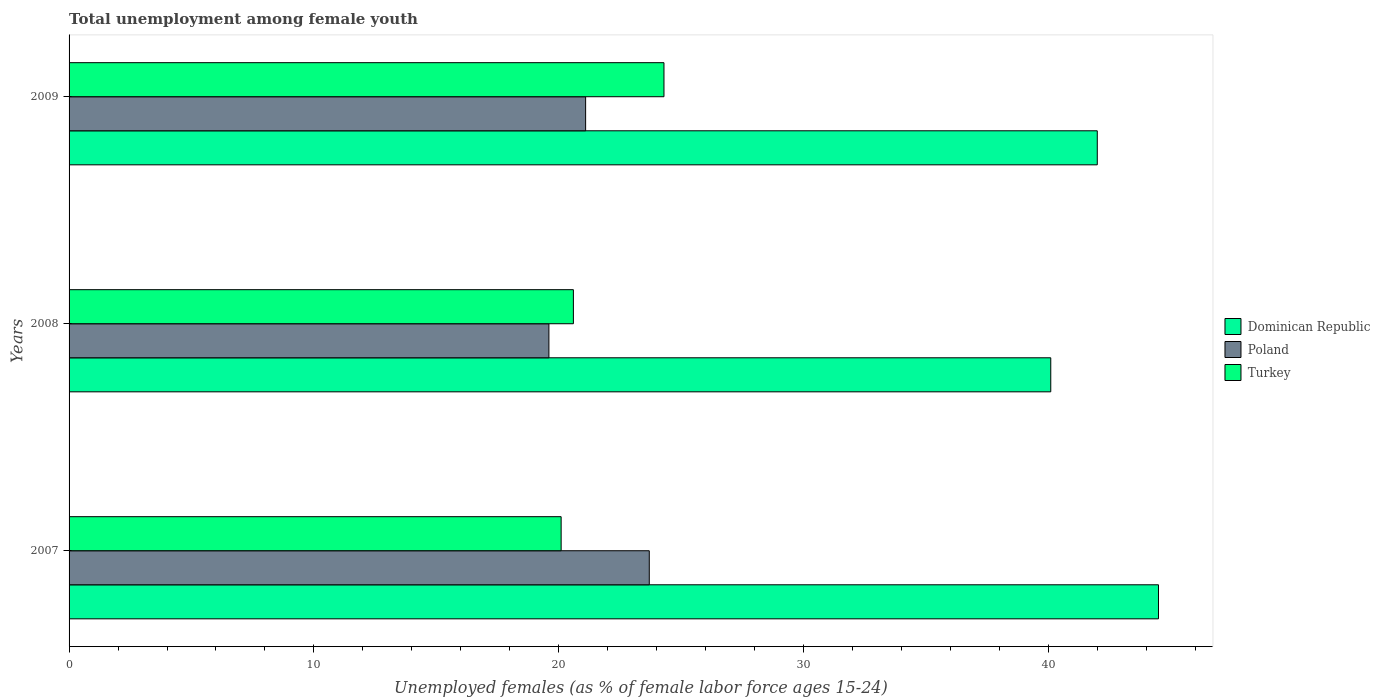How many different coloured bars are there?
Provide a succinct answer. 3. How many groups of bars are there?
Your answer should be compact. 3. Are the number of bars per tick equal to the number of legend labels?
Your answer should be very brief. Yes. Are the number of bars on each tick of the Y-axis equal?
Offer a terse response. Yes. How many bars are there on the 1st tick from the top?
Offer a very short reply. 3. What is the percentage of unemployed females in in Poland in 2008?
Provide a succinct answer. 19.6. Across all years, what is the maximum percentage of unemployed females in in Dominican Republic?
Keep it short and to the point. 44.5. Across all years, what is the minimum percentage of unemployed females in in Poland?
Provide a short and direct response. 19.6. In which year was the percentage of unemployed females in in Dominican Republic maximum?
Your answer should be compact. 2007. In which year was the percentage of unemployed females in in Turkey minimum?
Offer a terse response. 2007. What is the total percentage of unemployed females in in Dominican Republic in the graph?
Offer a very short reply. 126.6. What is the difference between the percentage of unemployed females in in Dominican Republic in 2008 and that in 2009?
Give a very brief answer. -1.9. What is the difference between the percentage of unemployed females in in Dominican Republic in 2009 and the percentage of unemployed females in in Poland in 2007?
Offer a very short reply. 18.3. What is the average percentage of unemployed females in in Turkey per year?
Keep it short and to the point. 21.67. In the year 2007, what is the difference between the percentage of unemployed females in in Turkey and percentage of unemployed females in in Dominican Republic?
Your response must be concise. -24.4. In how many years, is the percentage of unemployed females in in Dominican Republic greater than 12 %?
Your answer should be compact. 3. What is the ratio of the percentage of unemployed females in in Poland in 2008 to that in 2009?
Provide a short and direct response. 0.93. Is the percentage of unemployed females in in Turkey in 2007 less than that in 2009?
Your answer should be very brief. Yes. What is the difference between the highest and the second highest percentage of unemployed females in in Poland?
Give a very brief answer. 2.6. What is the difference between the highest and the lowest percentage of unemployed females in in Poland?
Offer a very short reply. 4.1. Is the sum of the percentage of unemployed females in in Poland in 2007 and 2009 greater than the maximum percentage of unemployed females in in Dominican Republic across all years?
Keep it short and to the point. Yes. What does the 2nd bar from the top in 2009 represents?
Keep it short and to the point. Poland. What does the 2nd bar from the bottom in 2007 represents?
Your response must be concise. Poland. Is it the case that in every year, the sum of the percentage of unemployed females in in Turkey and percentage of unemployed females in in Dominican Republic is greater than the percentage of unemployed females in in Poland?
Provide a short and direct response. Yes. Does the graph contain grids?
Provide a short and direct response. No. Where does the legend appear in the graph?
Your response must be concise. Center right. What is the title of the graph?
Offer a terse response. Total unemployment among female youth. Does "Djibouti" appear as one of the legend labels in the graph?
Your answer should be compact. No. What is the label or title of the X-axis?
Give a very brief answer. Unemployed females (as % of female labor force ages 15-24). What is the Unemployed females (as % of female labor force ages 15-24) of Dominican Republic in 2007?
Offer a very short reply. 44.5. What is the Unemployed females (as % of female labor force ages 15-24) of Poland in 2007?
Ensure brevity in your answer.  23.7. What is the Unemployed females (as % of female labor force ages 15-24) of Turkey in 2007?
Offer a terse response. 20.1. What is the Unemployed females (as % of female labor force ages 15-24) in Dominican Republic in 2008?
Your response must be concise. 40.1. What is the Unemployed females (as % of female labor force ages 15-24) of Poland in 2008?
Your response must be concise. 19.6. What is the Unemployed females (as % of female labor force ages 15-24) of Turkey in 2008?
Your response must be concise. 20.6. What is the Unemployed females (as % of female labor force ages 15-24) of Poland in 2009?
Offer a very short reply. 21.1. What is the Unemployed females (as % of female labor force ages 15-24) in Turkey in 2009?
Your answer should be very brief. 24.3. Across all years, what is the maximum Unemployed females (as % of female labor force ages 15-24) of Dominican Republic?
Keep it short and to the point. 44.5. Across all years, what is the maximum Unemployed females (as % of female labor force ages 15-24) in Poland?
Offer a terse response. 23.7. Across all years, what is the maximum Unemployed females (as % of female labor force ages 15-24) in Turkey?
Keep it short and to the point. 24.3. Across all years, what is the minimum Unemployed females (as % of female labor force ages 15-24) in Dominican Republic?
Provide a short and direct response. 40.1. Across all years, what is the minimum Unemployed females (as % of female labor force ages 15-24) in Poland?
Ensure brevity in your answer.  19.6. Across all years, what is the minimum Unemployed females (as % of female labor force ages 15-24) in Turkey?
Make the answer very short. 20.1. What is the total Unemployed females (as % of female labor force ages 15-24) in Dominican Republic in the graph?
Keep it short and to the point. 126.6. What is the total Unemployed females (as % of female labor force ages 15-24) of Poland in the graph?
Ensure brevity in your answer.  64.4. What is the total Unemployed females (as % of female labor force ages 15-24) in Turkey in the graph?
Your response must be concise. 65. What is the difference between the Unemployed females (as % of female labor force ages 15-24) of Poland in 2007 and that in 2008?
Offer a terse response. 4.1. What is the difference between the Unemployed females (as % of female labor force ages 15-24) of Poland in 2007 and that in 2009?
Give a very brief answer. 2.6. What is the difference between the Unemployed females (as % of female labor force ages 15-24) in Turkey in 2008 and that in 2009?
Offer a very short reply. -3.7. What is the difference between the Unemployed females (as % of female labor force ages 15-24) in Dominican Republic in 2007 and the Unemployed females (as % of female labor force ages 15-24) in Poland in 2008?
Ensure brevity in your answer.  24.9. What is the difference between the Unemployed females (as % of female labor force ages 15-24) of Dominican Republic in 2007 and the Unemployed females (as % of female labor force ages 15-24) of Turkey in 2008?
Keep it short and to the point. 23.9. What is the difference between the Unemployed females (as % of female labor force ages 15-24) in Dominican Republic in 2007 and the Unemployed females (as % of female labor force ages 15-24) in Poland in 2009?
Ensure brevity in your answer.  23.4. What is the difference between the Unemployed females (as % of female labor force ages 15-24) in Dominican Republic in 2007 and the Unemployed females (as % of female labor force ages 15-24) in Turkey in 2009?
Offer a very short reply. 20.2. What is the difference between the Unemployed females (as % of female labor force ages 15-24) in Poland in 2007 and the Unemployed females (as % of female labor force ages 15-24) in Turkey in 2009?
Your answer should be very brief. -0.6. What is the difference between the Unemployed females (as % of female labor force ages 15-24) of Poland in 2008 and the Unemployed females (as % of female labor force ages 15-24) of Turkey in 2009?
Ensure brevity in your answer.  -4.7. What is the average Unemployed females (as % of female labor force ages 15-24) of Dominican Republic per year?
Make the answer very short. 42.2. What is the average Unemployed females (as % of female labor force ages 15-24) of Poland per year?
Offer a terse response. 21.47. What is the average Unemployed females (as % of female labor force ages 15-24) in Turkey per year?
Offer a very short reply. 21.67. In the year 2007, what is the difference between the Unemployed females (as % of female labor force ages 15-24) of Dominican Republic and Unemployed females (as % of female labor force ages 15-24) of Poland?
Make the answer very short. 20.8. In the year 2007, what is the difference between the Unemployed females (as % of female labor force ages 15-24) of Dominican Republic and Unemployed females (as % of female labor force ages 15-24) of Turkey?
Give a very brief answer. 24.4. In the year 2007, what is the difference between the Unemployed females (as % of female labor force ages 15-24) in Poland and Unemployed females (as % of female labor force ages 15-24) in Turkey?
Your answer should be very brief. 3.6. In the year 2008, what is the difference between the Unemployed females (as % of female labor force ages 15-24) of Poland and Unemployed females (as % of female labor force ages 15-24) of Turkey?
Provide a succinct answer. -1. In the year 2009, what is the difference between the Unemployed females (as % of female labor force ages 15-24) of Dominican Republic and Unemployed females (as % of female labor force ages 15-24) of Poland?
Give a very brief answer. 20.9. In the year 2009, what is the difference between the Unemployed females (as % of female labor force ages 15-24) in Poland and Unemployed females (as % of female labor force ages 15-24) in Turkey?
Keep it short and to the point. -3.2. What is the ratio of the Unemployed females (as % of female labor force ages 15-24) in Dominican Republic in 2007 to that in 2008?
Make the answer very short. 1.11. What is the ratio of the Unemployed females (as % of female labor force ages 15-24) in Poland in 2007 to that in 2008?
Ensure brevity in your answer.  1.21. What is the ratio of the Unemployed females (as % of female labor force ages 15-24) in Turkey in 2007 to that in 2008?
Provide a short and direct response. 0.98. What is the ratio of the Unemployed females (as % of female labor force ages 15-24) of Dominican Republic in 2007 to that in 2009?
Keep it short and to the point. 1.06. What is the ratio of the Unemployed females (as % of female labor force ages 15-24) in Poland in 2007 to that in 2009?
Offer a very short reply. 1.12. What is the ratio of the Unemployed females (as % of female labor force ages 15-24) of Turkey in 2007 to that in 2009?
Give a very brief answer. 0.83. What is the ratio of the Unemployed females (as % of female labor force ages 15-24) of Dominican Republic in 2008 to that in 2009?
Your answer should be very brief. 0.95. What is the ratio of the Unemployed females (as % of female labor force ages 15-24) in Poland in 2008 to that in 2009?
Your answer should be compact. 0.93. What is the ratio of the Unemployed females (as % of female labor force ages 15-24) in Turkey in 2008 to that in 2009?
Ensure brevity in your answer.  0.85. What is the difference between the highest and the second highest Unemployed females (as % of female labor force ages 15-24) in Dominican Republic?
Keep it short and to the point. 2.5. What is the difference between the highest and the second highest Unemployed females (as % of female labor force ages 15-24) in Poland?
Make the answer very short. 2.6. What is the difference between the highest and the lowest Unemployed females (as % of female labor force ages 15-24) of Turkey?
Your answer should be compact. 4.2. 